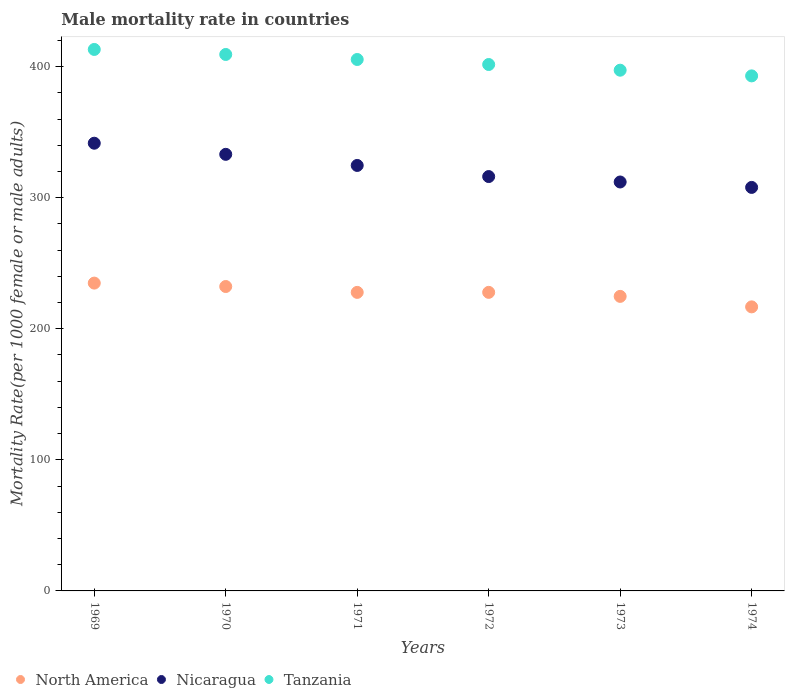How many different coloured dotlines are there?
Your response must be concise. 3. Is the number of dotlines equal to the number of legend labels?
Offer a very short reply. Yes. What is the male mortality rate in Tanzania in 1973?
Ensure brevity in your answer.  397.23. Across all years, what is the maximum male mortality rate in North America?
Provide a short and direct response. 234.82. Across all years, what is the minimum male mortality rate in Tanzania?
Your answer should be very brief. 392.89. In which year was the male mortality rate in North America maximum?
Provide a succinct answer. 1969. In which year was the male mortality rate in Tanzania minimum?
Your response must be concise. 1974. What is the total male mortality rate in Tanzania in the graph?
Your answer should be very brief. 2419.39. What is the difference between the male mortality rate in Tanzania in 1970 and that in 1971?
Make the answer very short. 3.83. What is the difference between the male mortality rate in Nicaragua in 1972 and the male mortality rate in North America in 1974?
Your answer should be compact. 99.41. What is the average male mortality rate in Tanzania per year?
Ensure brevity in your answer.  403.23. In the year 1969, what is the difference between the male mortality rate in North America and male mortality rate in Tanzania?
Give a very brief answer. -178.25. What is the ratio of the male mortality rate in Tanzania in 1972 to that in 1974?
Keep it short and to the point. 1.02. What is the difference between the highest and the second highest male mortality rate in Tanzania?
Give a very brief answer. 3.83. What is the difference between the highest and the lowest male mortality rate in North America?
Offer a terse response. 18.13. Is the sum of the male mortality rate in Nicaragua in 1973 and 1974 greater than the maximum male mortality rate in North America across all years?
Give a very brief answer. Yes. Is it the case that in every year, the sum of the male mortality rate in North America and male mortality rate in Tanzania  is greater than the male mortality rate in Nicaragua?
Keep it short and to the point. Yes. How many years are there in the graph?
Your answer should be very brief. 6. What is the difference between two consecutive major ticks on the Y-axis?
Your answer should be very brief. 100. How many legend labels are there?
Your response must be concise. 3. What is the title of the graph?
Provide a short and direct response. Male mortality rate in countries. Does "Curacao" appear as one of the legend labels in the graph?
Provide a succinct answer. No. What is the label or title of the Y-axis?
Offer a very short reply. Mortality Rate(per 1000 female or male adults). What is the Mortality Rate(per 1000 female or male adults) of North America in 1969?
Make the answer very short. 234.82. What is the Mortality Rate(per 1000 female or male adults) of Nicaragua in 1969?
Offer a very short reply. 341.53. What is the Mortality Rate(per 1000 female or male adults) of Tanzania in 1969?
Provide a short and direct response. 413.06. What is the Mortality Rate(per 1000 female or male adults) of North America in 1970?
Ensure brevity in your answer.  232.21. What is the Mortality Rate(per 1000 female or male adults) of Nicaragua in 1970?
Offer a very short reply. 333.05. What is the Mortality Rate(per 1000 female or male adults) in Tanzania in 1970?
Ensure brevity in your answer.  409.23. What is the Mortality Rate(per 1000 female or male adults) in North America in 1971?
Ensure brevity in your answer.  227.74. What is the Mortality Rate(per 1000 female or male adults) in Nicaragua in 1971?
Provide a succinct answer. 324.57. What is the Mortality Rate(per 1000 female or male adults) of Tanzania in 1971?
Make the answer very short. 405.4. What is the Mortality Rate(per 1000 female or male adults) of North America in 1972?
Ensure brevity in your answer.  227.76. What is the Mortality Rate(per 1000 female or male adults) in Nicaragua in 1972?
Ensure brevity in your answer.  316.09. What is the Mortality Rate(per 1000 female or male adults) in Tanzania in 1972?
Your answer should be compact. 401.57. What is the Mortality Rate(per 1000 female or male adults) in North America in 1973?
Offer a terse response. 224.69. What is the Mortality Rate(per 1000 female or male adults) of Nicaragua in 1973?
Provide a succinct answer. 311.95. What is the Mortality Rate(per 1000 female or male adults) of Tanzania in 1973?
Offer a very short reply. 397.23. What is the Mortality Rate(per 1000 female or male adults) of North America in 1974?
Your answer should be compact. 216.69. What is the Mortality Rate(per 1000 female or male adults) in Nicaragua in 1974?
Your response must be concise. 307.82. What is the Mortality Rate(per 1000 female or male adults) in Tanzania in 1974?
Offer a very short reply. 392.89. Across all years, what is the maximum Mortality Rate(per 1000 female or male adults) of North America?
Offer a very short reply. 234.82. Across all years, what is the maximum Mortality Rate(per 1000 female or male adults) in Nicaragua?
Provide a short and direct response. 341.53. Across all years, what is the maximum Mortality Rate(per 1000 female or male adults) of Tanzania?
Provide a succinct answer. 413.06. Across all years, what is the minimum Mortality Rate(per 1000 female or male adults) in North America?
Give a very brief answer. 216.69. Across all years, what is the minimum Mortality Rate(per 1000 female or male adults) of Nicaragua?
Offer a very short reply. 307.82. Across all years, what is the minimum Mortality Rate(per 1000 female or male adults) of Tanzania?
Your answer should be very brief. 392.89. What is the total Mortality Rate(per 1000 female or male adults) in North America in the graph?
Keep it short and to the point. 1363.9. What is the total Mortality Rate(per 1000 female or male adults) of Nicaragua in the graph?
Offer a very short reply. 1935.01. What is the total Mortality Rate(per 1000 female or male adults) of Tanzania in the graph?
Make the answer very short. 2419.39. What is the difference between the Mortality Rate(per 1000 female or male adults) of North America in 1969 and that in 1970?
Provide a succinct answer. 2.6. What is the difference between the Mortality Rate(per 1000 female or male adults) of Nicaragua in 1969 and that in 1970?
Your answer should be very brief. 8.48. What is the difference between the Mortality Rate(per 1000 female or male adults) of Tanzania in 1969 and that in 1970?
Offer a very short reply. 3.83. What is the difference between the Mortality Rate(per 1000 female or male adults) of North America in 1969 and that in 1971?
Provide a short and direct response. 7.08. What is the difference between the Mortality Rate(per 1000 female or male adults) in Nicaragua in 1969 and that in 1971?
Offer a very short reply. 16.96. What is the difference between the Mortality Rate(per 1000 female or male adults) in Tanzania in 1969 and that in 1971?
Give a very brief answer. 7.66. What is the difference between the Mortality Rate(per 1000 female or male adults) of North America in 1969 and that in 1972?
Provide a short and direct response. 7.06. What is the difference between the Mortality Rate(per 1000 female or male adults) of Nicaragua in 1969 and that in 1972?
Ensure brevity in your answer.  25.44. What is the difference between the Mortality Rate(per 1000 female or male adults) in Tanzania in 1969 and that in 1972?
Make the answer very short. 11.49. What is the difference between the Mortality Rate(per 1000 female or male adults) in North America in 1969 and that in 1973?
Provide a short and direct response. 10.12. What is the difference between the Mortality Rate(per 1000 female or male adults) in Nicaragua in 1969 and that in 1973?
Offer a very short reply. 29.57. What is the difference between the Mortality Rate(per 1000 female or male adults) of Tanzania in 1969 and that in 1973?
Make the answer very short. 15.83. What is the difference between the Mortality Rate(per 1000 female or male adults) in North America in 1969 and that in 1974?
Offer a very short reply. 18.13. What is the difference between the Mortality Rate(per 1000 female or male adults) in Nicaragua in 1969 and that in 1974?
Give a very brief answer. 33.71. What is the difference between the Mortality Rate(per 1000 female or male adults) in Tanzania in 1969 and that in 1974?
Provide a short and direct response. 20.17. What is the difference between the Mortality Rate(per 1000 female or male adults) in North America in 1970 and that in 1971?
Your response must be concise. 4.47. What is the difference between the Mortality Rate(per 1000 female or male adults) of Nicaragua in 1970 and that in 1971?
Your response must be concise. 8.48. What is the difference between the Mortality Rate(per 1000 female or male adults) of Tanzania in 1970 and that in 1971?
Your answer should be compact. 3.83. What is the difference between the Mortality Rate(per 1000 female or male adults) of North America in 1970 and that in 1972?
Your answer should be very brief. 4.46. What is the difference between the Mortality Rate(per 1000 female or male adults) in Nicaragua in 1970 and that in 1972?
Provide a succinct answer. 16.96. What is the difference between the Mortality Rate(per 1000 female or male adults) in Tanzania in 1970 and that in 1972?
Your answer should be very brief. 7.66. What is the difference between the Mortality Rate(per 1000 female or male adults) in North America in 1970 and that in 1973?
Provide a succinct answer. 7.52. What is the difference between the Mortality Rate(per 1000 female or male adults) in Nicaragua in 1970 and that in 1973?
Keep it short and to the point. 21.1. What is the difference between the Mortality Rate(per 1000 female or male adults) of Tanzania in 1970 and that in 1973?
Ensure brevity in your answer.  12. What is the difference between the Mortality Rate(per 1000 female or male adults) of North America in 1970 and that in 1974?
Offer a very short reply. 15.53. What is the difference between the Mortality Rate(per 1000 female or male adults) of Nicaragua in 1970 and that in 1974?
Offer a very short reply. 25.23. What is the difference between the Mortality Rate(per 1000 female or male adults) of Tanzania in 1970 and that in 1974?
Keep it short and to the point. 16.34. What is the difference between the Mortality Rate(per 1000 female or male adults) in North America in 1971 and that in 1972?
Provide a short and direct response. -0.02. What is the difference between the Mortality Rate(per 1000 female or male adults) in Nicaragua in 1971 and that in 1972?
Your answer should be very brief. 8.48. What is the difference between the Mortality Rate(per 1000 female or male adults) in Tanzania in 1971 and that in 1972?
Your answer should be compact. 3.83. What is the difference between the Mortality Rate(per 1000 female or male adults) of North America in 1971 and that in 1973?
Offer a terse response. 3.05. What is the difference between the Mortality Rate(per 1000 female or male adults) of Nicaragua in 1971 and that in 1973?
Your answer should be very brief. 12.62. What is the difference between the Mortality Rate(per 1000 female or male adults) in Tanzania in 1971 and that in 1973?
Offer a very short reply. 8.17. What is the difference between the Mortality Rate(per 1000 female or male adults) of North America in 1971 and that in 1974?
Your answer should be very brief. 11.05. What is the difference between the Mortality Rate(per 1000 female or male adults) of Nicaragua in 1971 and that in 1974?
Make the answer very short. 16.75. What is the difference between the Mortality Rate(per 1000 female or male adults) in Tanzania in 1971 and that in 1974?
Provide a short and direct response. 12.51. What is the difference between the Mortality Rate(per 1000 female or male adults) of North America in 1972 and that in 1973?
Ensure brevity in your answer.  3.07. What is the difference between the Mortality Rate(per 1000 female or male adults) of Nicaragua in 1972 and that in 1973?
Provide a short and direct response. 4.14. What is the difference between the Mortality Rate(per 1000 female or male adults) of Tanzania in 1972 and that in 1973?
Your response must be concise. 4.34. What is the difference between the Mortality Rate(per 1000 female or male adults) in North America in 1972 and that in 1974?
Your answer should be very brief. 11.07. What is the difference between the Mortality Rate(per 1000 female or male adults) in Nicaragua in 1972 and that in 1974?
Provide a short and direct response. 8.28. What is the difference between the Mortality Rate(per 1000 female or male adults) in Tanzania in 1972 and that in 1974?
Offer a very short reply. 8.68. What is the difference between the Mortality Rate(per 1000 female or male adults) in North America in 1973 and that in 1974?
Provide a short and direct response. 8.01. What is the difference between the Mortality Rate(per 1000 female or male adults) in Nicaragua in 1973 and that in 1974?
Your answer should be very brief. 4.14. What is the difference between the Mortality Rate(per 1000 female or male adults) of Tanzania in 1973 and that in 1974?
Your answer should be compact. 4.34. What is the difference between the Mortality Rate(per 1000 female or male adults) in North America in 1969 and the Mortality Rate(per 1000 female or male adults) in Nicaragua in 1970?
Give a very brief answer. -98.23. What is the difference between the Mortality Rate(per 1000 female or male adults) in North America in 1969 and the Mortality Rate(per 1000 female or male adults) in Tanzania in 1970?
Make the answer very short. -174.42. What is the difference between the Mortality Rate(per 1000 female or male adults) in Nicaragua in 1969 and the Mortality Rate(per 1000 female or male adults) in Tanzania in 1970?
Your answer should be very brief. -67.7. What is the difference between the Mortality Rate(per 1000 female or male adults) in North America in 1969 and the Mortality Rate(per 1000 female or male adults) in Nicaragua in 1971?
Make the answer very short. -89.76. What is the difference between the Mortality Rate(per 1000 female or male adults) of North America in 1969 and the Mortality Rate(per 1000 female or male adults) of Tanzania in 1971?
Provide a succinct answer. -170.59. What is the difference between the Mortality Rate(per 1000 female or male adults) in Nicaragua in 1969 and the Mortality Rate(per 1000 female or male adults) in Tanzania in 1971?
Ensure brevity in your answer.  -63.87. What is the difference between the Mortality Rate(per 1000 female or male adults) of North America in 1969 and the Mortality Rate(per 1000 female or male adults) of Nicaragua in 1972?
Make the answer very short. -81.28. What is the difference between the Mortality Rate(per 1000 female or male adults) of North America in 1969 and the Mortality Rate(per 1000 female or male adults) of Tanzania in 1972?
Your answer should be very brief. -166.76. What is the difference between the Mortality Rate(per 1000 female or male adults) of Nicaragua in 1969 and the Mortality Rate(per 1000 female or male adults) of Tanzania in 1972?
Offer a very short reply. -60.04. What is the difference between the Mortality Rate(per 1000 female or male adults) of North America in 1969 and the Mortality Rate(per 1000 female or male adults) of Nicaragua in 1973?
Your answer should be very brief. -77.14. What is the difference between the Mortality Rate(per 1000 female or male adults) in North America in 1969 and the Mortality Rate(per 1000 female or male adults) in Tanzania in 1973?
Give a very brief answer. -162.42. What is the difference between the Mortality Rate(per 1000 female or male adults) in Nicaragua in 1969 and the Mortality Rate(per 1000 female or male adults) in Tanzania in 1973?
Offer a terse response. -55.7. What is the difference between the Mortality Rate(per 1000 female or male adults) of North America in 1969 and the Mortality Rate(per 1000 female or male adults) of Nicaragua in 1974?
Your answer should be compact. -73. What is the difference between the Mortality Rate(per 1000 female or male adults) in North America in 1969 and the Mortality Rate(per 1000 female or male adults) in Tanzania in 1974?
Provide a short and direct response. -158.08. What is the difference between the Mortality Rate(per 1000 female or male adults) of Nicaragua in 1969 and the Mortality Rate(per 1000 female or male adults) of Tanzania in 1974?
Your response must be concise. -51.36. What is the difference between the Mortality Rate(per 1000 female or male adults) of North America in 1970 and the Mortality Rate(per 1000 female or male adults) of Nicaragua in 1971?
Keep it short and to the point. -92.36. What is the difference between the Mortality Rate(per 1000 female or male adults) in North America in 1970 and the Mortality Rate(per 1000 female or male adults) in Tanzania in 1971?
Keep it short and to the point. -173.19. What is the difference between the Mortality Rate(per 1000 female or male adults) of Nicaragua in 1970 and the Mortality Rate(per 1000 female or male adults) of Tanzania in 1971?
Make the answer very short. -72.35. What is the difference between the Mortality Rate(per 1000 female or male adults) of North America in 1970 and the Mortality Rate(per 1000 female or male adults) of Nicaragua in 1972?
Make the answer very short. -83.88. What is the difference between the Mortality Rate(per 1000 female or male adults) in North America in 1970 and the Mortality Rate(per 1000 female or male adults) in Tanzania in 1972?
Give a very brief answer. -169.36. What is the difference between the Mortality Rate(per 1000 female or male adults) in Nicaragua in 1970 and the Mortality Rate(per 1000 female or male adults) in Tanzania in 1972?
Keep it short and to the point. -68.52. What is the difference between the Mortality Rate(per 1000 female or male adults) of North America in 1970 and the Mortality Rate(per 1000 female or male adults) of Nicaragua in 1973?
Your answer should be compact. -79.74. What is the difference between the Mortality Rate(per 1000 female or male adults) in North America in 1970 and the Mortality Rate(per 1000 female or male adults) in Tanzania in 1973?
Give a very brief answer. -165.02. What is the difference between the Mortality Rate(per 1000 female or male adults) in Nicaragua in 1970 and the Mortality Rate(per 1000 female or male adults) in Tanzania in 1973?
Offer a very short reply. -64.18. What is the difference between the Mortality Rate(per 1000 female or male adults) of North America in 1970 and the Mortality Rate(per 1000 female or male adults) of Nicaragua in 1974?
Provide a short and direct response. -75.6. What is the difference between the Mortality Rate(per 1000 female or male adults) of North America in 1970 and the Mortality Rate(per 1000 female or male adults) of Tanzania in 1974?
Keep it short and to the point. -160.68. What is the difference between the Mortality Rate(per 1000 female or male adults) of Nicaragua in 1970 and the Mortality Rate(per 1000 female or male adults) of Tanzania in 1974?
Give a very brief answer. -59.84. What is the difference between the Mortality Rate(per 1000 female or male adults) of North America in 1971 and the Mortality Rate(per 1000 female or male adults) of Nicaragua in 1972?
Make the answer very short. -88.35. What is the difference between the Mortality Rate(per 1000 female or male adults) in North America in 1971 and the Mortality Rate(per 1000 female or male adults) in Tanzania in 1972?
Your answer should be very brief. -173.83. What is the difference between the Mortality Rate(per 1000 female or male adults) in Nicaragua in 1971 and the Mortality Rate(per 1000 female or male adults) in Tanzania in 1972?
Your answer should be very brief. -77. What is the difference between the Mortality Rate(per 1000 female or male adults) in North America in 1971 and the Mortality Rate(per 1000 female or male adults) in Nicaragua in 1973?
Give a very brief answer. -84.21. What is the difference between the Mortality Rate(per 1000 female or male adults) in North America in 1971 and the Mortality Rate(per 1000 female or male adults) in Tanzania in 1973?
Make the answer very short. -169.49. What is the difference between the Mortality Rate(per 1000 female or male adults) in Nicaragua in 1971 and the Mortality Rate(per 1000 female or male adults) in Tanzania in 1973?
Your answer should be very brief. -72.66. What is the difference between the Mortality Rate(per 1000 female or male adults) in North America in 1971 and the Mortality Rate(per 1000 female or male adults) in Nicaragua in 1974?
Provide a short and direct response. -80.08. What is the difference between the Mortality Rate(per 1000 female or male adults) in North America in 1971 and the Mortality Rate(per 1000 female or male adults) in Tanzania in 1974?
Your answer should be compact. -165.15. What is the difference between the Mortality Rate(per 1000 female or male adults) of Nicaragua in 1971 and the Mortality Rate(per 1000 female or male adults) of Tanzania in 1974?
Keep it short and to the point. -68.32. What is the difference between the Mortality Rate(per 1000 female or male adults) of North America in 1972 and the Mortality Rate(per 1000 female or male adults) of Nicaragua in 1973?
Make the answer very short. -84.2. What is the difference between the Mortality Rate(per 1000 female or male adults) in North America in 1972 and the Mortality Rate(per 1000 female or male adults) in Tanzania in 1973?
Give a very brief answer. -169.47. What is the difference between the Mortality Rate(per 1000 female or male adults) of Nicaragua in 1972 and the Mortality Rate(per 1000 female or male adults) of Tanzania in 1973?
Keep it short and to the point. -81.14. What is the difference between the Mortality Rate(per 1000 female or male adults) in North America in 1972 and the Mortality Rate(per 1000 female or male adults) in Nicaragua in 1974?
Provide a succinct answer. -80.06. What is the difference between the Mortality Rate(per 1000 female or male adults) in North America in 1972 and the Mortality Rate(per 1000 female or male adults) in Tanzania in 1974?
Keep it short and to the point. -165.13. What is the difference between the Mortality Rate(per 1000 female or male adults) of Nicaragua in 1972 and the Mortality Rate(per 1000 female or male adults) of Tanzania in 1974?
Offer a very short reply. -76.8. What is the difference between the Mortality Rate(per 1000 female or male adults) of North America in 1973 and the Mortality Rate(per 1000 female or male adults) of Nicaragua in 1974?
Keep it short and to the point. -83.13. What is the difference between the Mortality Rate(per 1000 female or male adults) of North America in 1973 and the Mortality Rate(per 1000 female or male adults) of Tanzania in 1974?
Provide a short and direct response. -168.2. What is the difference between the Mortality Rate(per 1000 female or male adults) in Nicaragua in 1973 and the Mortality Rate(per 1000 female or male adults) in Tanzania in 1974?
Provide a succinct answer. -80.94. What is the average Mortality Rate(per 1000 female or male adults) in North America per year?
Offer a terse response. 227.32. What is the average Mortality Rate(per 1000 female or male adults) of Nicaragua per year?
Your answer should be compact. 322.5. What is the average Mortality Rate(per 1000 female or male adults) of Tanzania per year?
Your answer should be compact. 403.23. In the year 1969, what is the difference between the Mortality Rate(per 1000 female or male adults) in North America and Mortality Rate(per 1000 female or male adults) in Nicaragua?
Your response must be concise. -106.71. In the year 1969, what is the difference between the Mortality Rate(per 1000 female or male adults) of North America and Mortality Rate(per 1000 female or male adults) of Tanzania?
Offer a terse response. -178.25. In the year 1969, what is the difference between the Mortality Rate(per 1000 female or male adults) of Nicaragua and Mortality Rate(per 1000 female or male adults) of Tanzania?
Offer a very short reply. -71.53. In the year 1970, what is the difference between the Mortality Rate(per 1000 female or male adults) of North America and Mortality Rate(per 1000 female or male adults) of Nicaragua?
Keep it short and to the point. -100.84. In the year 1970, what is the difference between the Mortality Rate(per 1000 female or male adults) in North America and Mortality Rate(per 1000 female or male adults) in Tanzania?
Your response must be concise. -177.02. In the year 1970, what is the difference between the Mortality Rate(per 1000 female or male adults) in Nicaragua and Mortality Rate(per 1000 female or male adults) in Tanzania?
Offer a very short reply. -76.18. In the year 1971, what is the difference between the Mortality Rate(per 1000 female or male adults) of North America and Mortality Rate(per 1000 female or male adults) of Nicaragua?
Your answer should be compact. -96.83. In the year 1971, what is the difference between the Mortality Rate(per 1000 female or male adults) of North America and Mortality Rate(per 1000 female or male adults) of Tanzania?
Your answer should be compact. -177.66. In the year 1971, what is the difference between the Mortality Rate(per 1000 female or male adults) of Nicaragua and Mortality Rate(per 1000 female or male adults) of Tanzania?
Give a very brief answer. -80.83. In the year 1972, what is the difference between the Mortality Rate(per 1000 female or male adults) of North America and Mortality Rate(per 1000 female or male adults) of Nicaragua?
Give a very brief answer. -88.33. In the year 1972, what is the difference between the Mortality Rate(per 1000 female or male adults) in North America and Mortality Rate(per 1000 female or male adults) in Tanzania?
Your response must be concise. -173.81. In the year 1972, what is the difference between the Mortality Rate(per 1000 female or male adults) of Nicaragua and Mortality Rate(per 1000 female or male adults) of Tanzania?
Ensure brevity in your answer.  -85.48. In the year 1973, what is the difference between the Mortality Rate(per 1000 female or male adults) in North America and Mortality Rate(per 1000 female or male adults) in Nicaragua?
Give a very brief answer. -87.26. In the year 1973, what is the difference between the Mortality Rate(per 1000 female or male adults) of North America and Mortality Rate(per 1000 female or male adults) of Tanzania?
Provide a short and direct response. -172.54. In the year 1973, what is the difference between the Mortality Rate(per 1000 female or male adults) in Nicaragua and Mortality Rate(per 1000 female or male adults) in Tanzania?
Your answer should be very brief. -85.28. In the year 1974, what is the difference between the Mortality Rate(per 1000 female or male adults) of North America and Mortality Rate(per 1000 female or male adults) of Nicaragua?
Offer a very short reply. -91.13. In the year 1974, what is the difference between the Mortality Rate(per 1000 female or male adults) of North America and Mortality Rate(per 1000 female or male adults) of Tanzania?
Offer a terse response. -176.21. In the year 1974, what is the difference between the Mortality Rate(per 1000 female or male adults) in Nicaragua and Mortality Rate(per 1000 female or male adults) in Tanzania?
Provide a short and direct response. -85.08. What is the ratio of the Mortality Rate(per 1000 female or male adults) of North America in 1969 to that in 1970?
Offer a terse response. 1.01. What is the ratio of the Mortality Rate(per 1000 female or male adults) of Nicaragua in 1969 to that in 1970?
Give a very brief answer. 1.03. What is the ratio of the Mortality Rate(per 1000 female or male adults) of Tanzania in 1969 to that in 1970?
Your answer should be very brief. 1.01. What is the ratio of the Mortality Rate(per 1000 female or male adults) of North America in 1969 to that in 1971?
Provide a short and direct response. 1.03. What is the ratio of the Mortality Rate(per 1000 female or male adults) of Nicaragua in 1969 to that in 1971?
Your answer should be compact. 1.05. What is the ratio of the Mortality Rate(per 1000 female or male adults) in Tanzania in 1969 to that in 1971?
Your response must be concise. 1.02. What is the ratio of the Mortality Rate(per 1000 female or male adults) of North America in 1969 to that in 1972?
Make the answer very short. 1.03. What is the ratio of the Mortality Rate(per 1000 female or male adults) of Nicaragua in 1969 to that in 1972?
Your response must be concise. 1.08. What is the ratio of the Mortality Rate(per 1000 female or male adults) in Tanzania in 1969 to that in 1972?
Provide a succinct answer. 1.03. What is the ratio of the Mortality Rate(per 1000 female or male adults) of North America in 1969 to that in 1973?
Provide a short and direct response. 1.05. What is the ratio of the Mortality Rate(per 1000 female or male adults) of Nicaragua in 1969 to that in 1973?
Give a very brief answer. 1.09. What is the ratio of the Mortality Rate(per 1000 female or male adults) of Tanzania in 1969 to that in 1973?
Offer a very short reply. 1.04. What is the ratio of the Mortality Rate(per 1000 female or male adults) in North America in 1969 to that in 1974?
Ensure brevity in your answer.  1.08. What is the ratio of the Mortality Rate(per 1000 female or male adults) in Nicaragua in 1969 to that in 1974?
Ensure brevity in your answer.  1.11. What is the ratio of the Mortality Rate(per 1000 female or male adults) of Tanzania in 1969 to that in 1974?
Your answer should be very brief. 1.05. What is the ratio of the Mortality Rate(per 1000 female or male adults) of North America in 1970 to that in 1971?
Make the answer very short. 1.02. What is the ratio of the Mortality Rate(per 1000 female or male adults) of Nicaragua in 1970 to that in 1971?
Your answer should be compact. 1.03. What is the ratio of the Mortality Rate(per 1000 female or male adults) of Tanzania in 1970 to that in 1971?
Give a very brief answer. 1.01. What is the ratio of the Mortality Rate(per 1000 female or male adults) in North America in 1970 to that in 1972?
Provide a succinct answer. 1.02. What is the ratio of the Mortality Rate(per 1000 female or male adults) of Nicaragua in 1970 to that in 1972?
Offer a very short reply. 1.05. What is the ratio of the Mortality Rate(per 1000 female or male adults) in Tanzania in 1970 to that in 1972?
Your answer should be compact. 1.02. What is the ratio of the Mortality Rate(per 1000 female or male adults) of North America in 1970 to that in 1973?
Ensure brevity in your answer.  1.03. What is the ratio of the Mortality Rate(per 1000 female or male adults) in Nicaragua in 1970 to that in 1973?
Make the answer very short. 1.07. What is the ratio of the Mortality Rate(per 1000 female or male adults) of Tanzania in 1970 to that in 1973?
Offer a terse response. 1.03. What is the ratio of the Mortality Rate(per 1000 female or male adults) of North America in 1970 to that in 1974?
Provide a short and direct response. 1.07. What is the ratio of the Mortality Rate(per 1000 female or male adults) in Nicaragua in 1970 to that in 1974?
Your answer should be compact. 1.08. What is the ratio of the Mortality Rate(per 1000 female or male adults) in Tanzania in 1970 to that in 1974?
Offer a very short reply. 1.04. What is the ratio of the Mortality Rate(per 1000 female or male adults) in North America in 1971 to that in 1972?
Ensure brevity in your answer.  1. What is the ratio of the Mortality Rate(per 1000 female or male adults) of Nicaragua in 1971 to that in 1972?
Provide a short and direct response. 1.03. What is the ratio of the Mortality Rate(per 1000 female or male adults) of Tanzania in 1971 to that in 1972?
Provide a short and direct response. 1.01. What is the ratio of the Mortality Rate(per 1000 female or male adults) in North America in 1971 to that in 1973?
Keep it short and to the point. 1.01. What is the ratio of the Mortality Rate(per 1000 female or male adults) of Nicaragua in 1971 to that in 1973?
Your answer should be very brief. 1.04. What is the ratio of the Mortality Rate(per 1000 female or male adults) in Tanzania in 1971 to that in 1973?
Offer a terse response. 1.02. What is the ratio of the Mortality Rate(per 1000 female or male adults) in North America in 1971 to that in 1974?
Make the answer very short. 1.05. What is the ratio of the Mortality Rate(per 1000 female or male adults) of Nicaragua in 1971 to that in 1974?
Your response must be concise. 1.05. What is the ratio of the Mortality Rate(per 1000 female or male adults) in Tanzania in 1971 to that in 1974?
Ensure brevity in your answer.  1.03. What is the ratio of the Mortality Rate(per 1000 female or male adults) in North America in 1972 to that in 1973?
Offer a very short reply. 1.01. What is the ratio of the Mortality Rate(per 1000 female or male adults) of Nicaragua in 1972 to that in 1973?
Keep it short and to the point. 1.01. What is the ratio of the Mortality Rate(per 1000 female or male adults) in Tanzania in 1972 to that in 1973?
Provide a succinct answer. 1.01. What is the ratio of the Mortality Rate(per 1000 female or male adults) of North America in 1972 to that in 1974?
Give a very brief answer. 1.05. What is the ratio of the Mortality Rate(per 1000 female or male adults) in Nicaragua in 1972 to that in 1974?
Give a very brief answer. 1.03. What is the ratio of the Mortality Rate(per 1000 female or male adults) of Tanzania in 1972 to that in 1974?
Offer a terse response. 1.02. What is the ratio of the Mortality Rate(per 1000 female or male adults) of North America in 1973 to that in 1974?
Provide a succinct answer. 1.04. What is the ratio of the Mortality Rate(per 1000 female or male adults) of Nicaragua in 1973 to that in 1974?
Ensure brevity in your answer.  1.01. What is the difference between the highest and the second highest Mortality Rate(per 1000 female or male adults) of North America?
Offer a very short reply. 2.6. What is the difference between the highest and the second highest Mortality Rate(per 1000 female or male adults) in Nicaragua?
Provide a succinct answer. 8.48. What is the difference between the highest and the second highest Mortality Rate(per 1000 female or male adults) in Tanzania?
Your answer should be compact. 3.83. What is the difference between the highest and the lowest Mortality Rate(per 1000 female or male adults) of North America?
Your answer should be compact. 18.13. What is the difference between the highest and the lowest Mortality Rate(per 1000 female or male adults) of Nicaragua?
Offer a terse response. 33.71. What is the difference between the highest and the lowest Mortality Rate(per 1000 female or male adults) of Tanzania?
Your response must be concise. 20.17. 